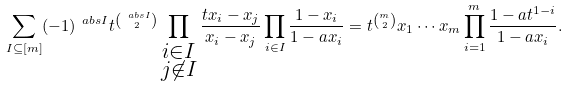Convert formula to latex. <formula><loc_0><loc_0><loc_500><loc_500>\sum _ { I \subseteq [ m ] } ( - 1 ) ^ { \ a b s { I } } t ^ { \binom { \ a b s { I } } { 2 } } \prod _ { \substack { i \in I \\ j \not \in I } } \frac { t x _ { i } - x _ { j } } { x _ { i } - x _ { j } } \prod _ { i \in I } \frac { 1 - x _ { i } } { 1 - a x _ { i } } = t ^ { \binom { m } { 2 } } x _ { 1 } \cdots x _ { m } \prod _ { i = 1 } ^ { m } \frac { 1 - a t ^ { 1 - i } } { 1 - a x _ { i } } .</formula> 